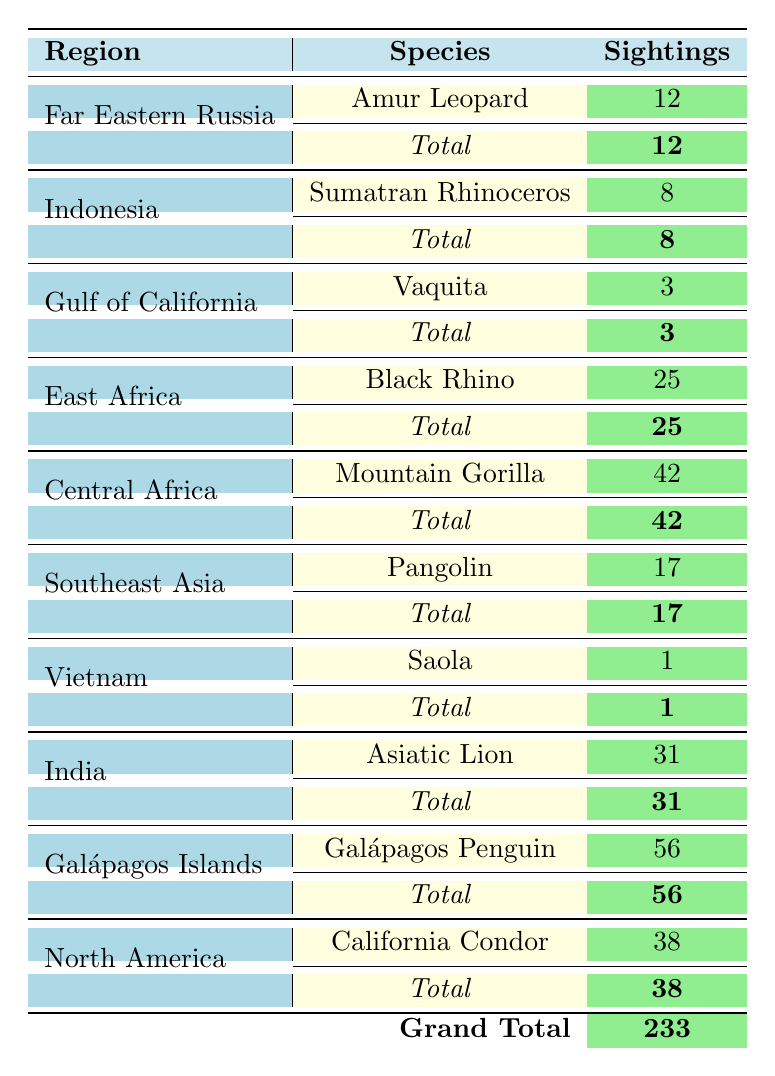What is the total number of sightings for the Amur Leopard? The table shows that there is only one row for the Amur Leopard, which indicates 12 sightings for this species.
Answer: 12 Which region has the highest number of endangered species sightings? By checking the "Sightings" column, the Galápagos Islands have the highest number of sightings, with a total of 56 for the Galápagos Penguin.
Answer: Galápagos Islands What is the total number of sightings across all regions? The total number of sightings is obtained by adding all the individual sightings: 12 + 8 + 3 + 25 + 42 + 17 + 1 + 31 + 56 + 38 = 233. Therefore, the grand total is 233.
Answer: 233 Is the Black Rhino considered critically endangered? In the "Conservation Status" column, the Black Rhino is marked as "Critically Endangered." Therefore, the statement is true.
Answer: Yes What is the difference in sightings between the Mountain Gorilla and the California Condor? The Mountain Gorilla has 42 sightings, while the California Condor has 38 sightings. The difference is calculated as 42 - 38 = 4.
Answer: 4 How many species are observed in Southeast Asia, and what is the total number of sightings for that region? Only the Pangolin is listed for Southeast Asia, with a total of 17 sightings. Therefore, there is 1 species with 17 sightings.
Answer: 1 species, 17 sightings Which species has the fewest sightings, and how many sightings does it have? Looking through the table, the Saola has only 1 sighting, which is the lowest count portrayed in the table.
Answer: Saola, 1 sighting What is the average number of sightings per species across all observations? There are 10 species listed in total with 233 sightings. The average is calculated as 233 sightings / 10 species = 23.3.
Answer: 23.3 Does the Sumatran Rhinoceros have more sightings than the Vaquita? The Sumatran Rhinoceros has 8 sightings, while the Vaquita has only 3 sightings. Therefore, the Sumatran Rhinoceros has more sightings than the Vaquita.
Answer: Yes Which illustration technique is used for the California Condor? According to the "Illustration Technique" column, the California Condor's illustration technique is listed as "Charcoal."
Answer: Charcoal 